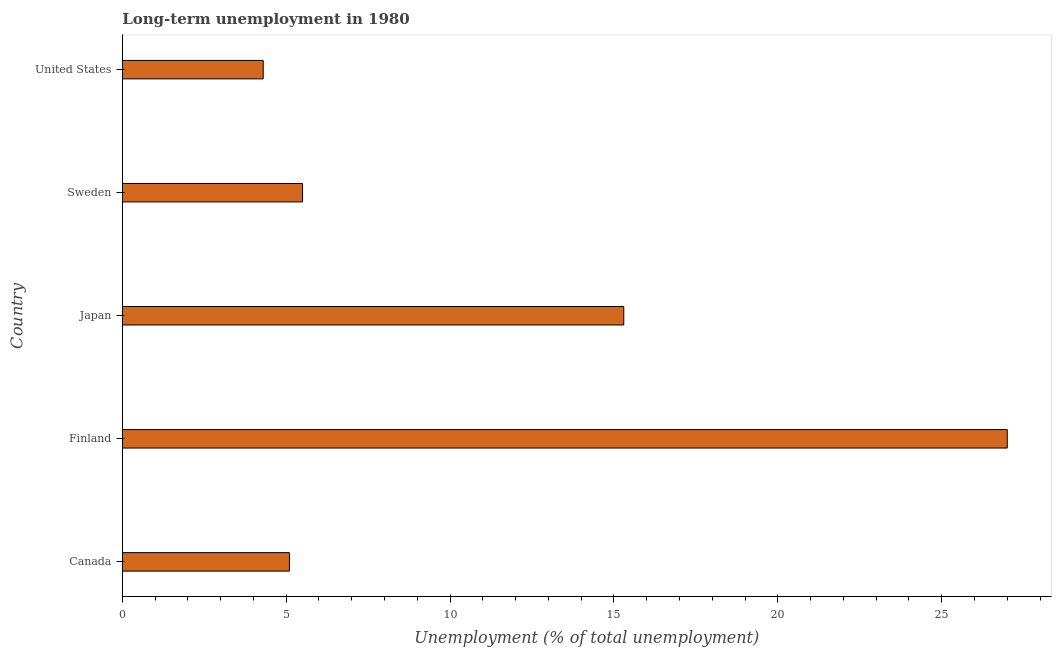Does the graph contain grids?
Make the answer very short. No. What is the title of the graph?
Keep it short and to the point. Long-term unemployment in 1980. What is the label or title of the X-axis?
Your response must be concise. Unemployment (% of total unemployment). Across all countries, what is the maximum long-term unemployment?
Your answer should be compact. 27. Across all countries, what is the minimum long-term unemployment?
Your answer should be very brief. 4.3. In which country was the long-term unemployment minimum?
Ensure brevity in your answer.  United States. What is the sum of the long-term unemployment?
Your answer should be very brief. 57.2. What is the difference between the long-term unemployment in Canada and Finland?
Provide a short and direct response. -21.9. What is the average long-term unemployment per country?
Your answer should be compact. 11.44. What is the median long-term unemployment?
Provide a short and direct response. 5.5. In how many countries, is the long-term unemployment greater than 24 %?
Keep it short and to the point. 1. What is the ratio of the long-term unemployment in Finland to that in Japan?
Your response must be concise. 1.76. Is the long-term unemployment in Canada less than that in Japan?
Ensure brevity in your answer.  Yes. What is the difference between the highest and the second highest long-term unemployment?
Give a very brief answer. 11.7. What is the difference between the highest and the lowest long-term unemployment?
Make the answer very short. 22.7. How many bars are there?
Make the answer very short. 5. What is the Unemployment (% of total unemployment) in Canada?
Make the answer very short. 5.1. What is the Unemployment (% of total unemployment) of Japan?
Provide a short and direct response. 15.3. What is the Unemployment (% of total unemployment) of Sweden?
Provide a short and direct response. 5.5. What is the Unemployment (% of total unemployment) in United States?
Ensure brevity in your answer.  4.3. What is the difference between the Unemployment (% of total unemployment) in Canada and Finland?
Offer a terse response. -21.9. What is the difference between the Unemployment (% of total unemployment) in Canada and Sweden?
Offer a terse response. -0.4. What is the difference between the Unemployment (% of total unemployment) in Finland and Japan?
Make the answer very short. 11.7. What is the difference between the Unemployment (% of total unemployment) in Finland and United States?
Provide a short and direct response. 22.7. What is the difference between the Unemployment (% of total unemployment) in Japan and Sweden?
Offer a very short reply. 9.8. What is the ratio of the Unemployment (% of total unemployment) in Canada to that in Finland?
Your answer should be very brief. 0.19. What is the ratio of the Unemployment (% of total unemployment) in Canada to that in Japan?
Your answer should be compact. 0.33. What is the ratio of the Unemployment (% of total unemployment) in Canada to that in Sweden?
Your answer should be very brief. 0.93. What is the ratio of the Unemployment (% of total unemployment) in Canada to that in United States?
Provide a succinct answer. 1.19. What is the ratio of the Unemployment (% of total unemployment) in Finland to that in Japan?
Give a very brief answer. 1.76. What is the ratio of the Unemployment (% of total unemployment) in Finland to that in Sweden?
Offer a terse response. 4.91. What is the ratio of the Unemployment (% of total unemployment) in Finland to that in United States?
Offer a very short reply. 6.28. What is the ratio of the Unemployment (% of total unemployment) in Japan to that in Sweden?
Keep it short and to the point. 2.78. What is the ratio of the Unemployment (% of total unemployment) in Japan to that in United States?
Your response must be concise. 3.56. What is the ratio of the Unemployment (% of total unemployment) in Sweden to that in United States?
Provide a succinct answer. 1.28. 